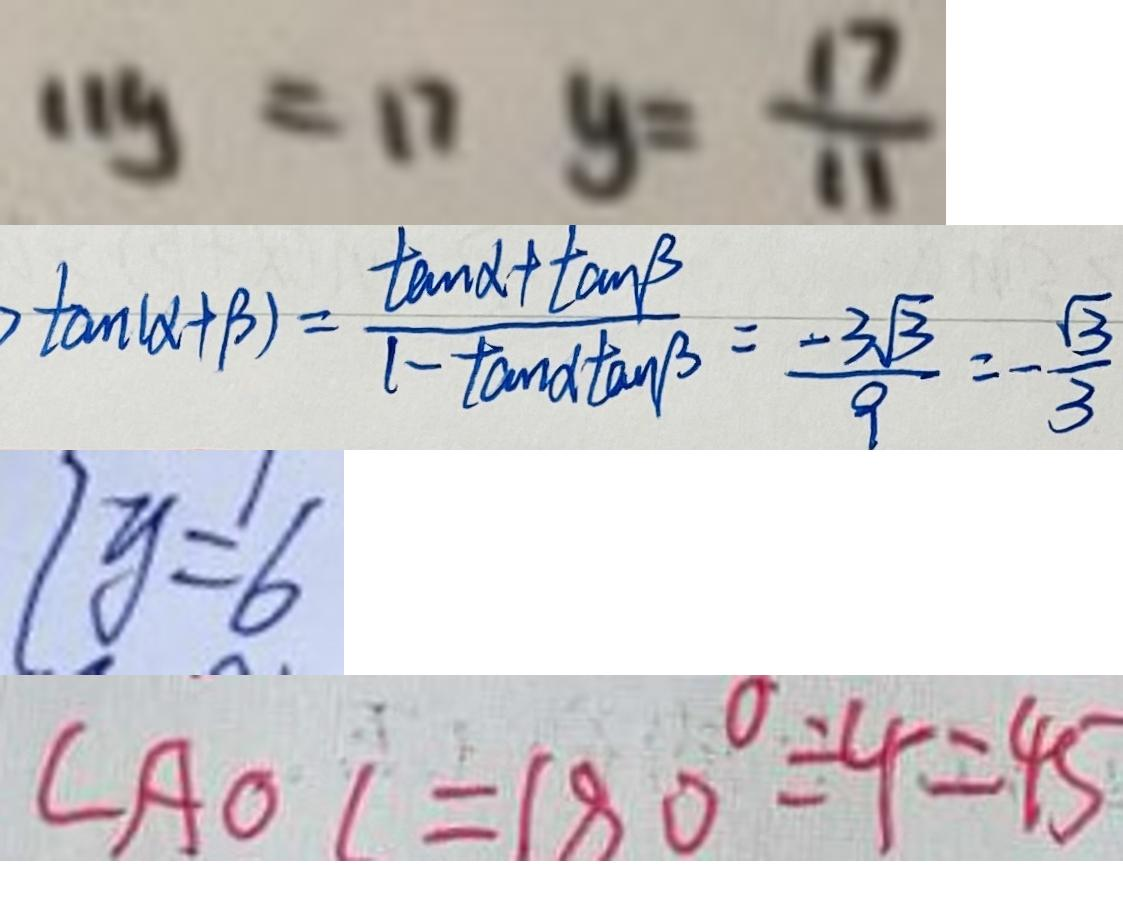Convert formula to latex. <formula><loc_0><loc_0><loc_500><loc_500>1 1 y = 1 7 y = \frac { 1 7 } { 1 1 } 
 \tan ( \alpha + \beta ) = \frac { \tan \alpha + \tan \beta } { 1 - \tan \alpha \tan \beta } = \frac { - 3 \sqrt { 3 } } { 9 } = - \frac { \sqrt { 3 } } { 3 } 
 2 y = 6 
 \angle A O C = 1 8 0 ^ { \circ } \div 4 = 4 5</formula> 